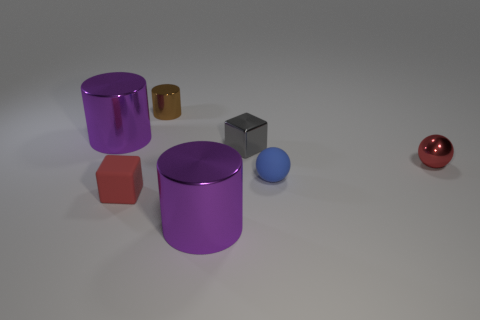What might the different shapes and sizes of these objects suggest about their uses? The diversity in shape and size among these objects could indicate a variety of uses. The larger purple cylinders could be storage containers, the brown cubes might be decorative elements or paperweights, the small spheres could serve as marbles or bearings, and the gray block might be a calibration weight or a doorstop. The objects' shapes and sizes afford certain functions and suggest their intended interaction with the environment or with other objects. 